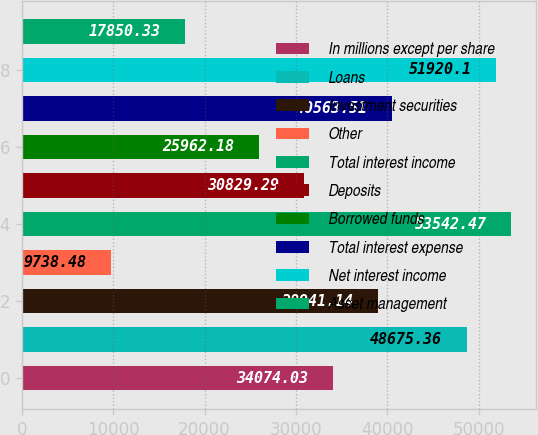Convert chart. <chart><loc_0><loc_0><loc_500><loc_500><bar_chart><fcel>In millions except per share<fcel>Loans<fcel>Investment securities<fcel>Other<fcel>Total interest income<fcel>Deposits<fcel>Borrowed funds<fcel>Total interest expense<fcel>Net interest income<fcel>Asset management<nl><fcel>34074<fcel>48675.4<fcel>38941.1<fcel>9738.48<fcel>53542.5<fcel>30829.3<fcel>25962.2<fcel>40563.5<fcel>51920.1<fcel>17850.3<nl></chart> 